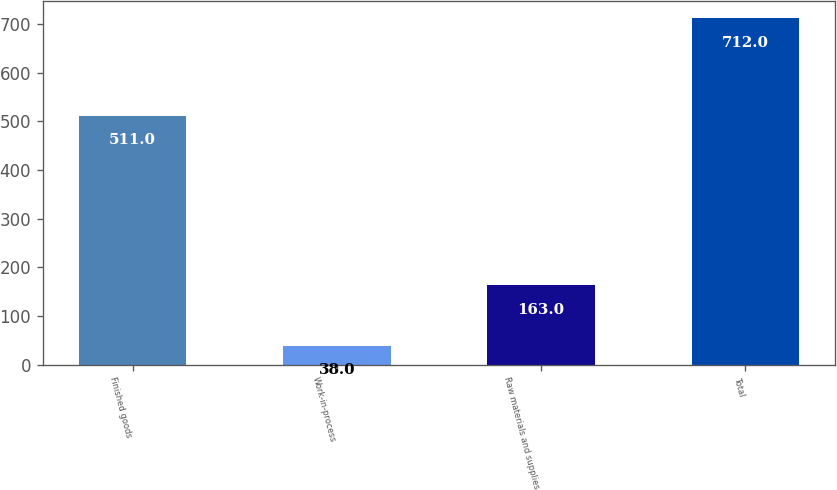<chart> <loc_0><loc_0><loc_500><loc_500><bar_chart><fcel>Finished goods<fcel>Work-in-process<fcel>Raw materials and supplies<fcel>Total<nl><fcel>511<fcel>38<fcel>163<fcel>712<nl></chart> 